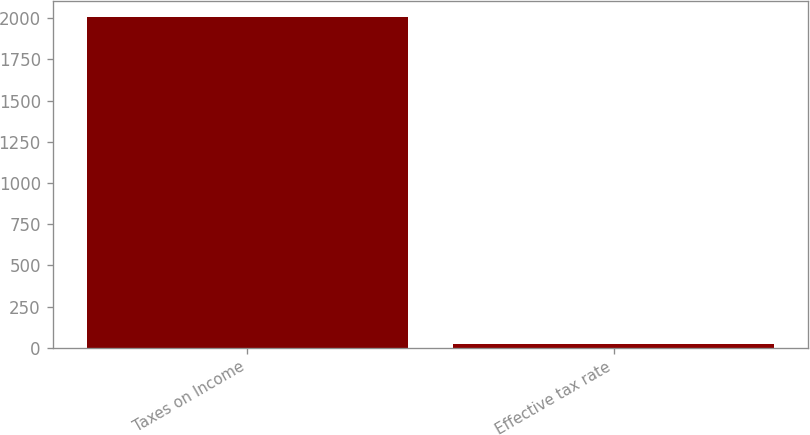Convert chart to OTSL. <chart><loc_0><loc_0><loc_500><loc_500><bar_chart><fcel>Taxes on Income<fcel>Effective tax rate<nl><fcel>2005<fcel>20.4<nl></chart> 